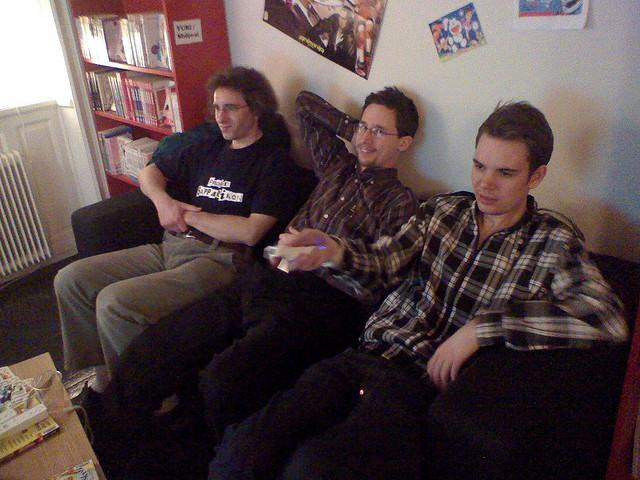What are these people engaging in? Please explain your reasoning. video game. The man on the right is holding a controller that is used for playing nintendo wii, a popular video game console. 